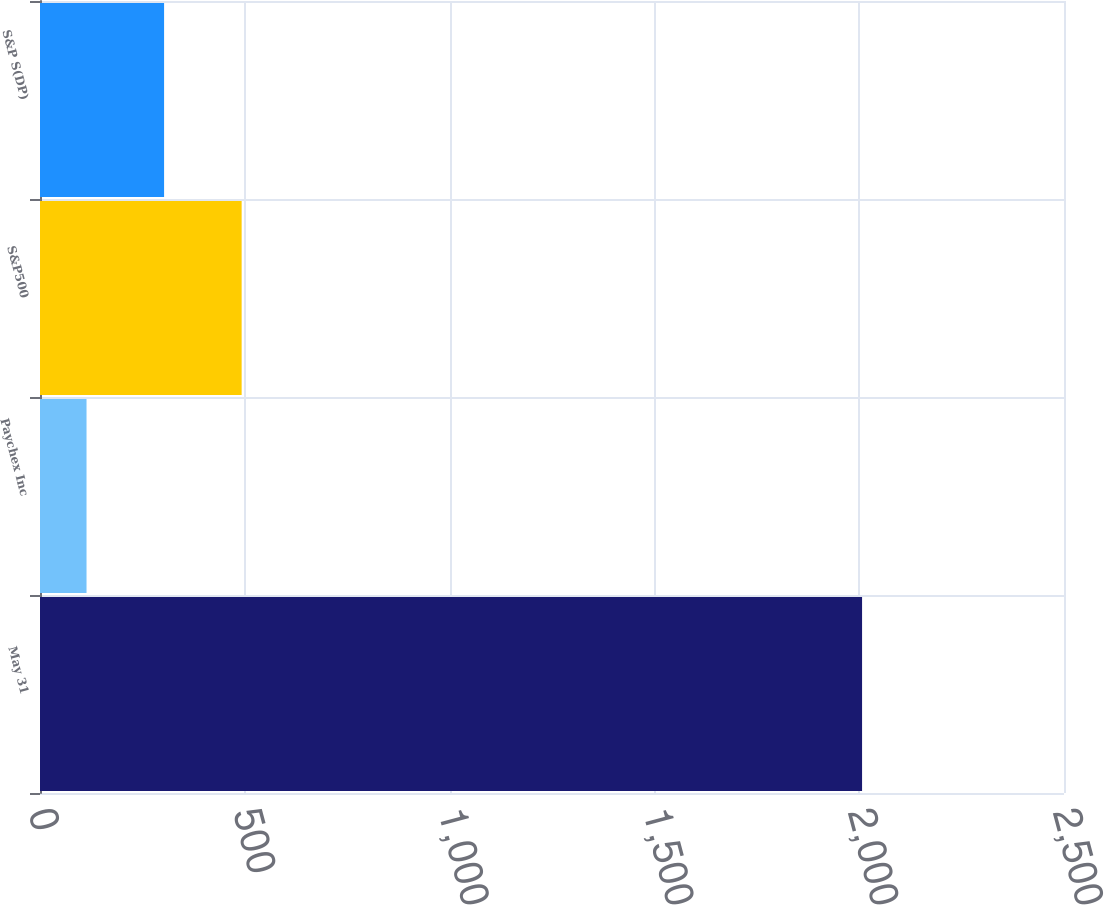Convert chart. <chart><loc_0><loc_0><loc_500><loc_500><bar_chart><fcel>May 31<fcel>Paychex Inc<fcel>S&P500<fcel>S&P S(DP)<nl><fcel>2007<fcel>113.6<fcel>492.28<fcel>302.94<nl></chart> 